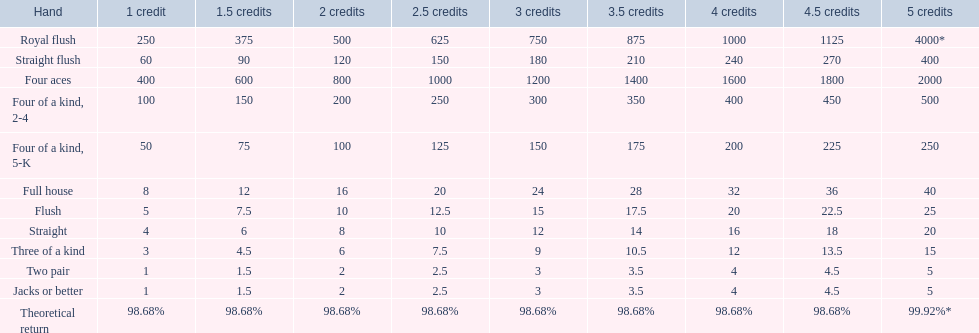How many credits do you have to spend to get at least 2000 in payout if you had four aces? 5 credits. 